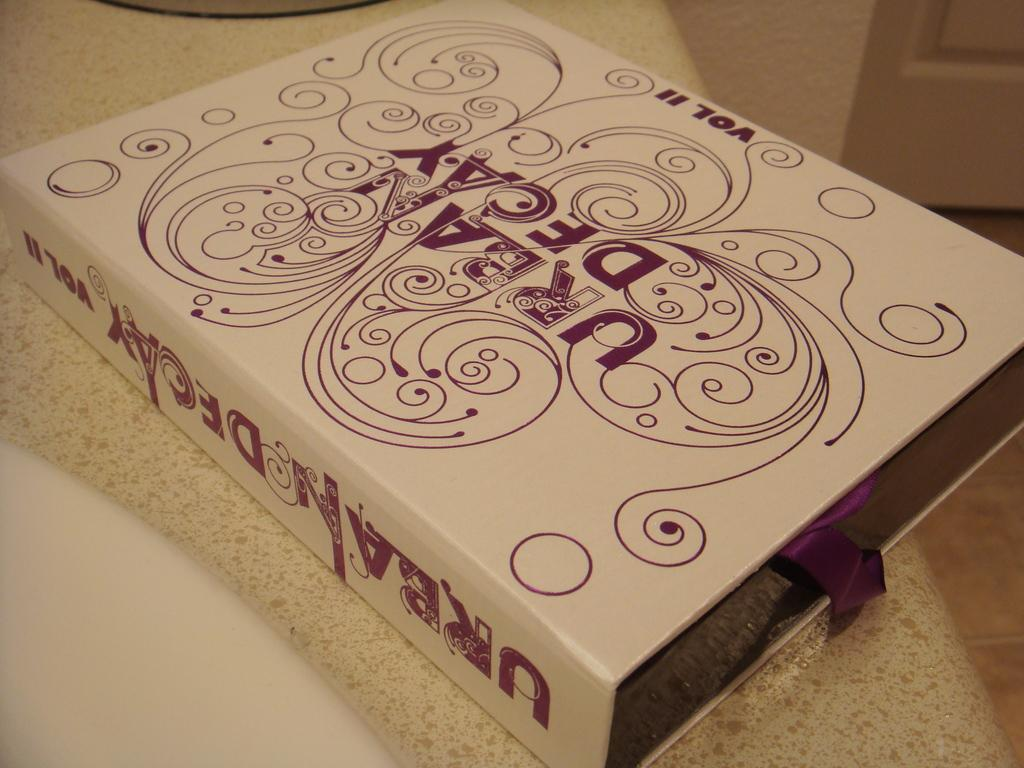<image>
Write a terse but informative summary of the picture. The box of Urban Decay volume II makeup sits on the bathroom counter top. 